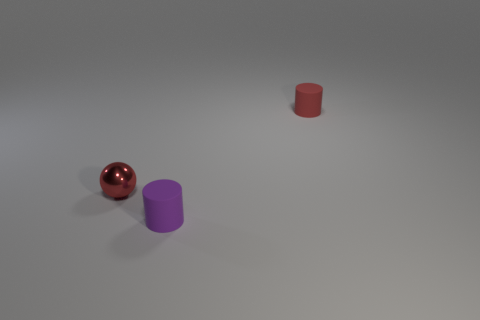Add 2 gray rubber cubes. How many objects exist? 5 Subtract all cylinders. How many objects are left? 1 Subtract 0 cyan cylinders. How many objects are left? 3 Subtract all tiny purple cylinders. Subtract all red shiny things. How many objects are left? 1 Add 1 rubber cylinders. How many rubber cylinders are left? 3 Add 2 green matte blocks. How many green matte blocks exist? 2 